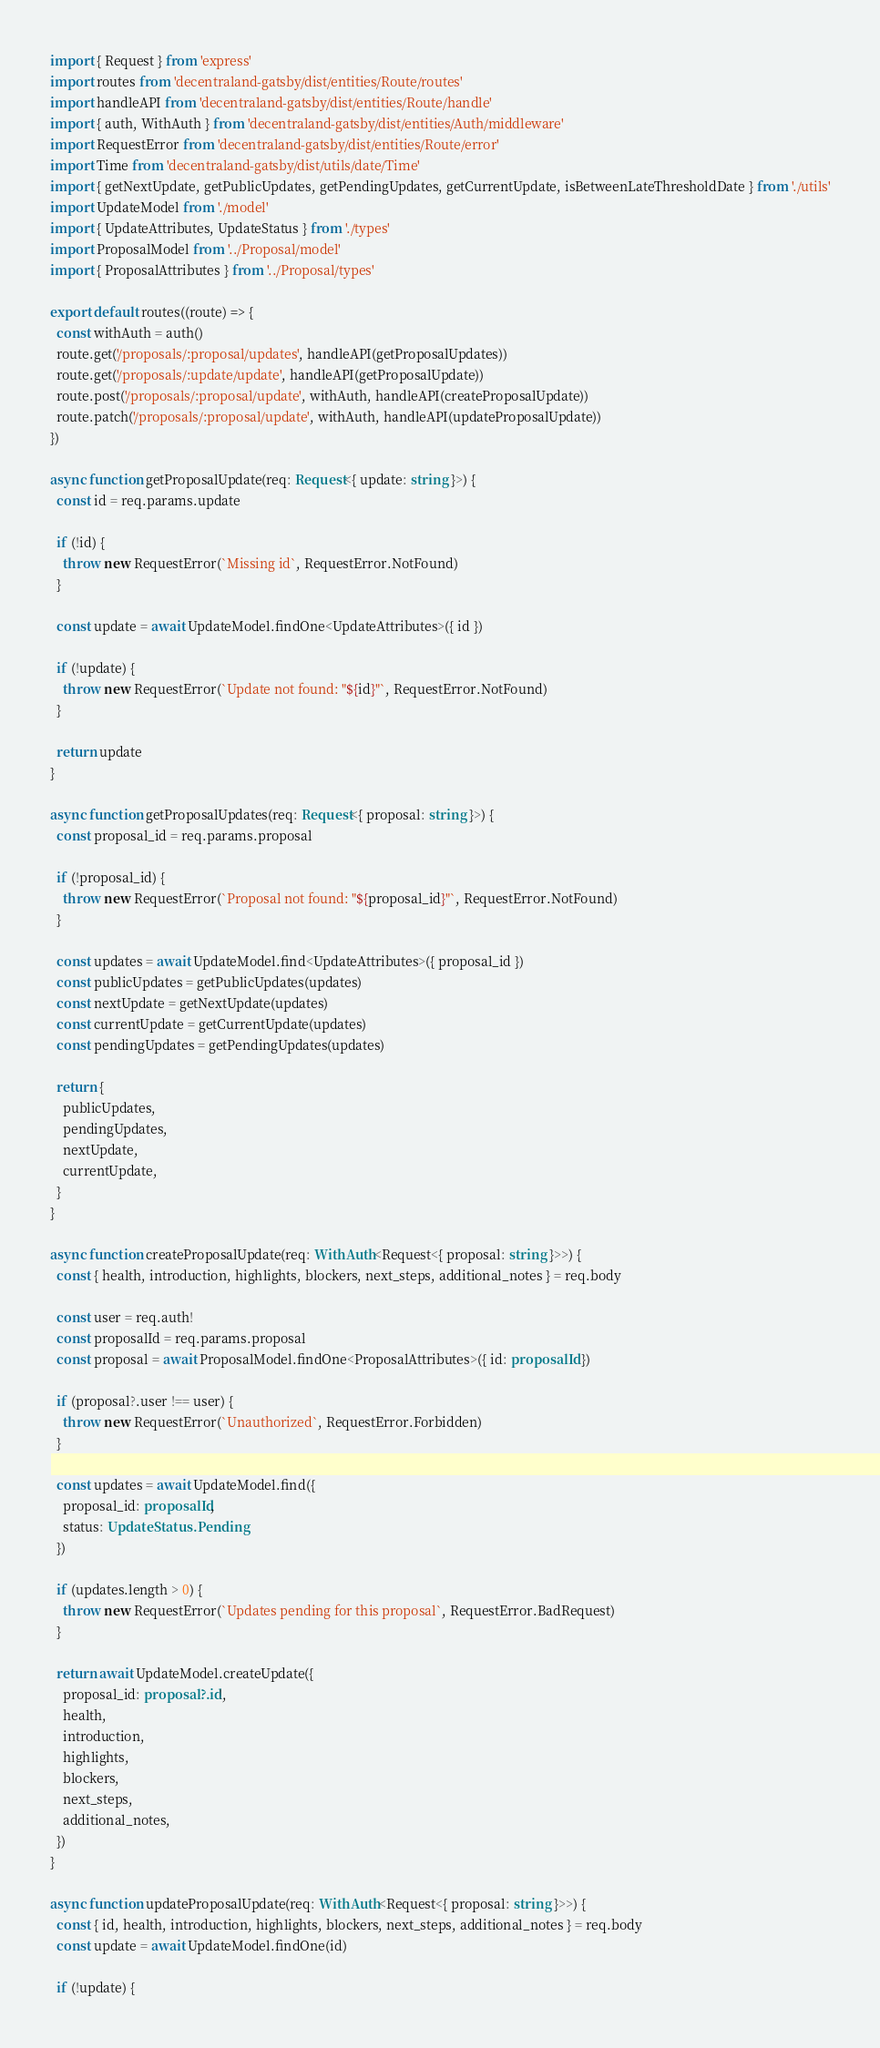Convert code to text. <code><loc_0><loc_0><loc_500><loc_500><_TypeScript_>import { Request } from 'express'
import routes from 'decentraland-gatsby/dist/entities/Route/routes'
import handleAPI from 'decentraland-gatsby/dist/entities/Route/handle'
import { auth, WithAuth } from 'decentraland-gatsby/dist/entities/Auth/middleware'
import RequestError from 'decentraland-gatsby/dist/entities/Route/error'
import Time from 'decentraland-gatsby/dist/utils/date/Time'
import { getNextUpdate, getPublicUpdates, getPendingUpdates, getCurrentUpdate, isBetweenLateThresholdDate } from './utils'
import UpdateModel from './model'
import { UpdateAttributes, UpdateStatus } from './types'
import ProposalModel from '../Proposal/model'
import { ProposalAttributes } from '../Proposal/types'

export default routes((route) => {
  const withAuth = auth()
  route.get('/proposals/:proposal/updates', handleAPI(getProposalUpdates))
  route.get('/proposals/:update/update', handleAPI(getProposalUpdate))
  route.post('/proposals/:proposal/update', withAuth, handleAPI(createProposalUpdate))
  route.patch('/proposals/:proposal/update', withAuth, handleAPI(updateProposalUpdate))
})

async function getProposalUpdate(req: Request<{ update: string }>) {
  const id = req.params.update

  if (!id) {
    throw new RequestError(`Missing id`, RequestError.NotFound)
  }

  const update = await UpdateModel.findOne<UpdateAttributes>({ id })

  if (!update) {
    throw new RequestError(`Update not found: "${id}"`, RequestError.NotFound)
  }

  return update
}

async function getProposalUpdates(req: Request<{ proposal: string }>) {
  const proposal_id = req.params.proposal

  if (!proposal_id) {
    throw new RequestError(`Proposal not found: "${proposal_id}"`, RequestError.NotFound)
  }

  const updates = await UpdateModel.find<UpdateAttributes>({ proposal_id })
  const publicUpdates = getPublicUpdates(updates)
  const nextUpdate = getNextUpdate(updates)
  const currentUpdate = getCurrentUpdate(updates)
  const pendingUpdates = getPendingUpdates(updates)

  return {
    publicUpdates,
    pendingUpdates,
    nextUpdate,
    currentUpdate,
  }
}

async function createProposalUpdate(req: WithAuth<Request<{ proposal: string }>>) {
  const { health, introduction, highlights, blockers, next_steps, additional_notes } = req.body

  const user = req.auth!
  const proposalId = req.params.proposal
  const proposal = await ProposalModel.findOne<ProposalAttributes>({ id: proposalId })

  if (proposal?.user !== user) {
    throw new RequestError(`Unauthorized`, RequestError.Forbidden)
  }

  const updates = await UpdateModel.find({
    proposal_id: proposalId,
    status: UpdateStatus.Pending
  })

  if (updates.length > 0) {
    throw new RequestError(`Updates pending for this proposal`, RequestError.BadRequest)
  }

  return await UpdateModel.createUpdate({
    proposal_id: proposal?.id!,
    health,
    introduction,
    highlights,
    blockers,
    next_steps,
    additional_notes,
  })
}

async function updateProposalUpdate(req: WithAuth<Request<{ proposal: string }>>) {
  const { id, health, introduction, highlights, blockers, next_steps, additional_notes } = req.body
  const update = await UpdateModel.findOne(id)

  if (!update) {</code> 